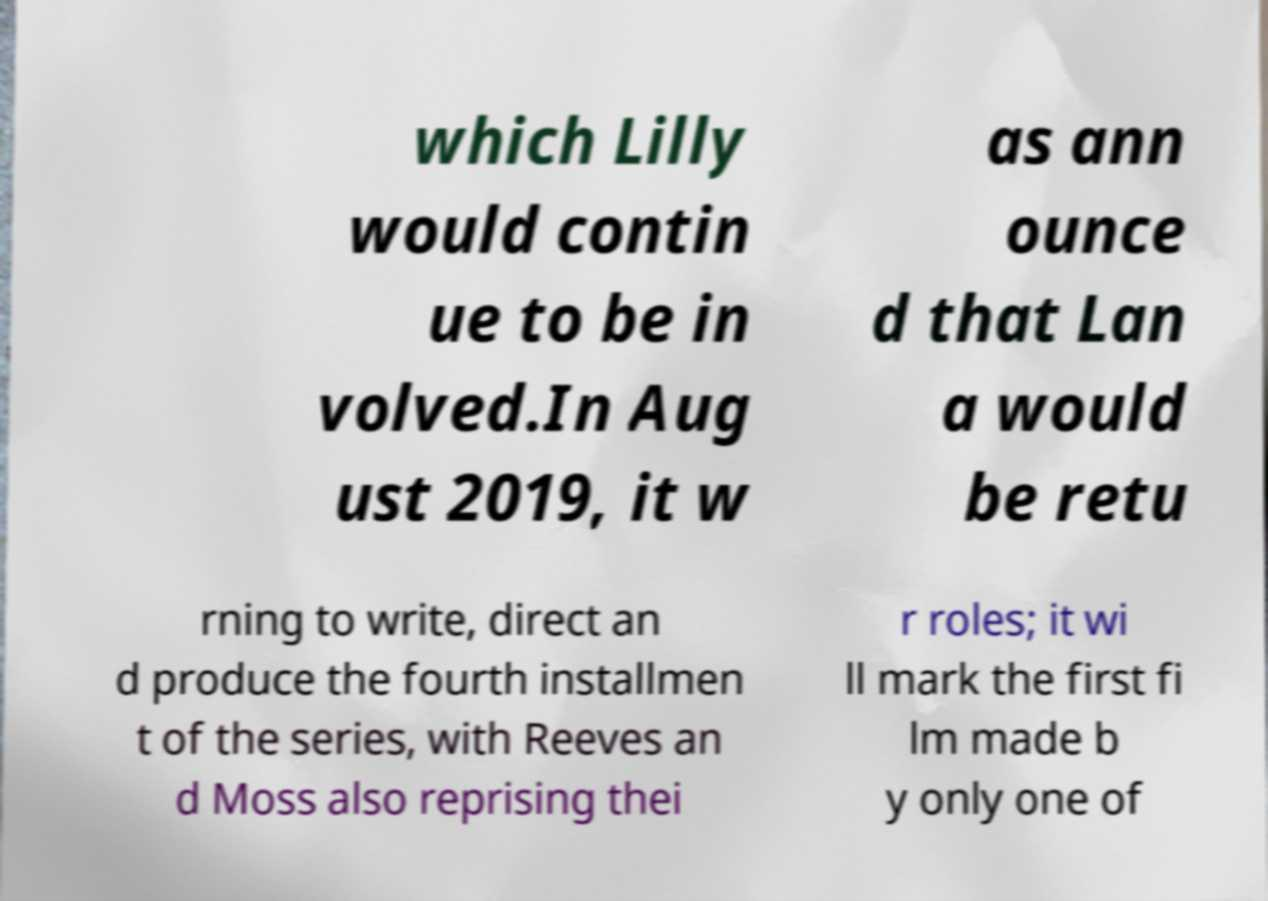Could you extract and type out the text from this image? which Lilly would contin ue to be in volved.In Aug ust 2019, it w as ann ounce d that Lan a would be retu rning to write, direct an d produce the fourth installmen t of the series, with Reeves an d Moss also reprising thei r roles; it wi ll mark the first fi lm made b y only one of 